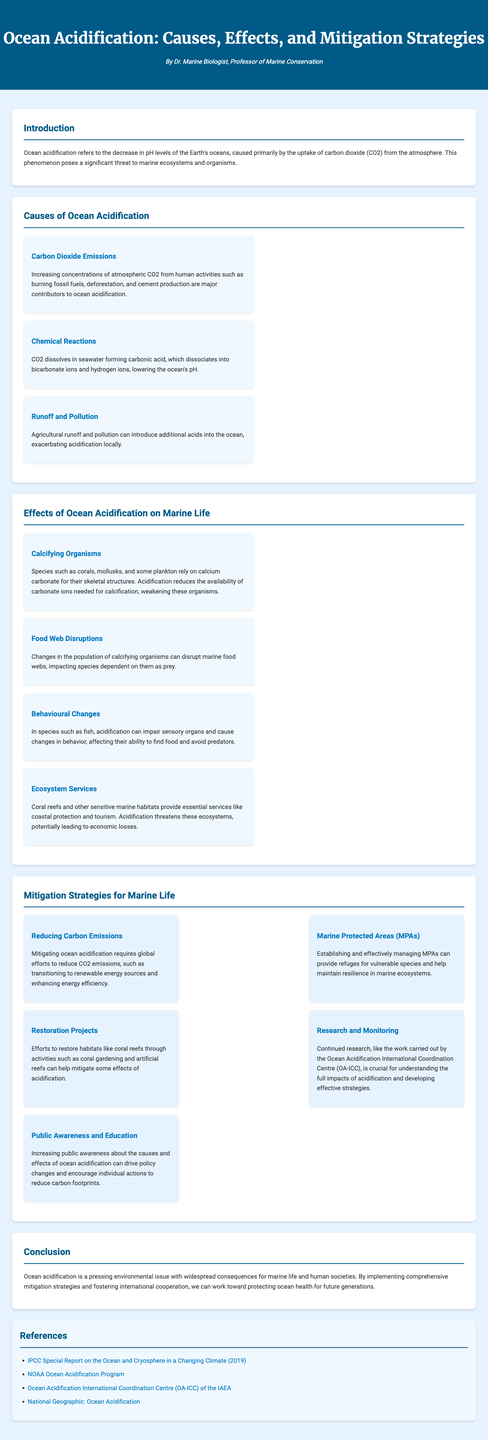What is ocean acidification? Ocean acidification refers to the decrease in pH levels of the Earth's oceans, caused primarily by the uptake of carbon dioxide (CO2) from the atmosphere.
Answer: Decrease in pH levels What are the three main causes of ocean acidification? The document lists carbon dioxide emissions, chemical reactions, and runoff and pollution as the main causes.
Answer: Carbon dioxide emissions, chemical reactions, runoff and pollution Which organisms are primarily affected by ocean acidification? The infographic mentions that calcifying organisms such as corals and mollusks are primarily affected.
Answer: Calcifying organisms What is one proposed mitigation strategy for marine life? The document suggests various strategies including reducing carbon emissions, marine protected areas, and restoration projects.
Answer: Reducing carbon emissions What negative effect does ocean acidification have on food webs? Changes in the population of calcifying organisms can disrupt marine food webs.
Answer: Disrupt food webs According to the document, what can increase public awareness? The document emphasizes that increasing public awareness about ocean acidification can drive policy changes.
Answer: Public awareness How does ocean acidification affect fish behavior? The infographic states that acidification can impair sensory organs and cause changes in behavior in fish.
Answer: Impair sensory organs, change behavior What organization is mentioned for continued research on ocean acidification? The document references the Ocean Acidification International Coordination Centre (OA-ICC) for continued research efforts.
Answer: OA-ICC 